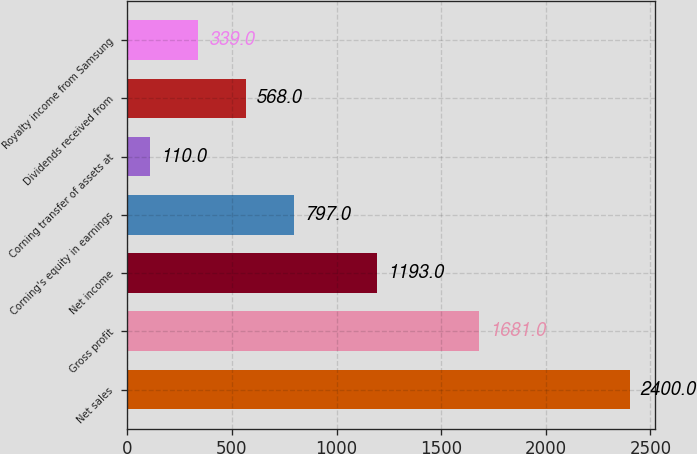Convert chart. <chart><loc_0><loc_0><loc_500><loc_500><bar_chart><fcel>Net sales<fcel>Gross profit<fcel>Net income<fcel>Corning's equity in earnings<fcel>Corning transfer of assets at<fcel>Dividends received from<fcel>Royalty income from Samsung<nl><fcel>2400<fcel>1681<fcel>1193<fcel>797<fcel>110<fcel>568<fcel>339<nl></chart> 